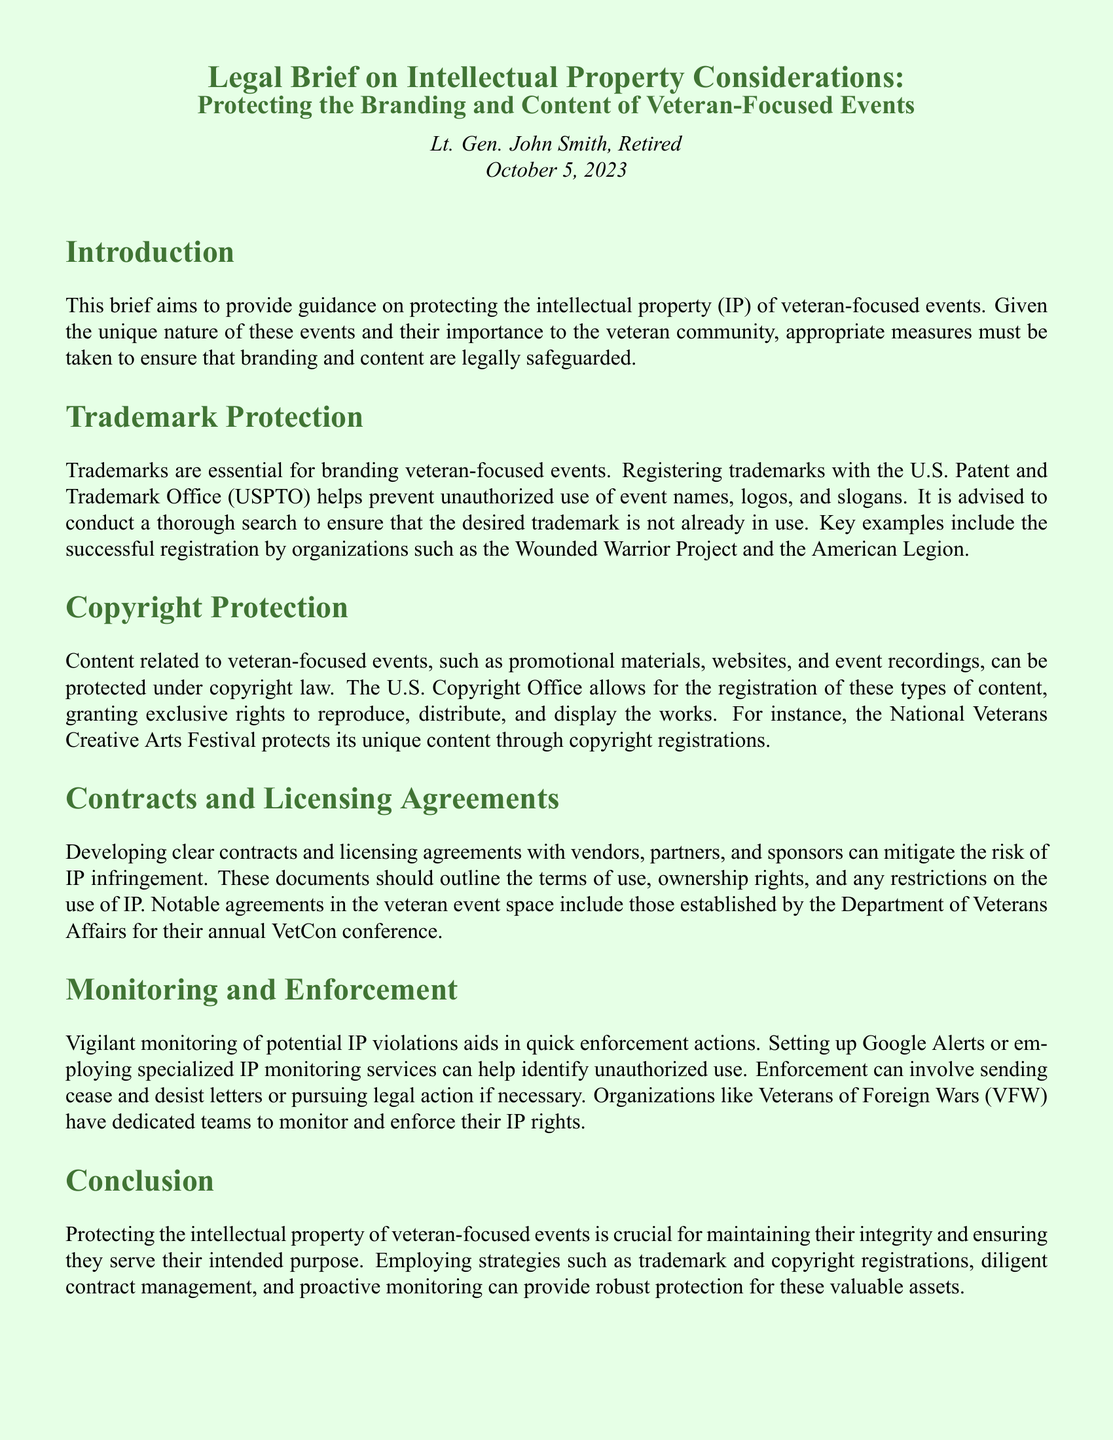What is the purpose of this brief? The purpose of the brief is to provide guidance on protecting the intellectual property (IP) of veteran-focused events.
Answer: Protecting intellectual property of veteran-focused events Who authored the brief? The author of the brief is mentioned in the title section of the document.
Answer: Lt. Gen. John Smith, Retired When was the brief published? The publication date is provided at the end of the title section.
Answer: October 5, 2023 What organization is mentioned as having registered trademarks successfully? An example of an organization that has successfully registered trademarks is provided in the trademark protection section.
Answer: Wounded Warrior Project What type of content can be protected under copyright law? The copyright protection section states the types of content that can be protected.
Answer: Promotional materials, websites, event recordings Which event is cited as having copyright registrations? The document mentions an organization associated with a specific event that protects its content through copyright.
Answer: National Veterans Creative Arts Festival What is emphasized as a method of monitoring IP violations? The brief outlines a specific technique to monitor potential IP violations mentioned in the monitoring section.
Answer: Setting up Google Alerts What is a key document type for managing IP with vendors? The section on contracts indicates a specific type of document that clarifies relationships and rights regarding IP.
Answer: Contracts and licensing agreements What is the role of the Department of Veterans Affairs in IP protection? A notable agreement established by the Department of Veterans Affairs for an event is referenced in the contracts section.
Answer: VetCon conference 